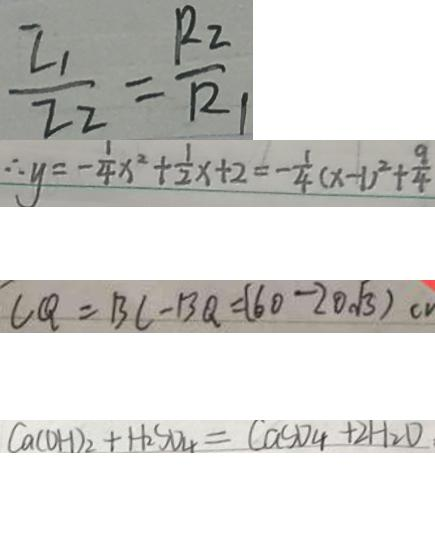<formula> <loc_0><loc_0><loc_500><loc_500>\frac { I _ { 1 } } { I _ { 2 } } = \frac { R 2 } { R _ { 1 } } 
 \therefore y = - \frac { 1 } { 4 } x ^ { 2 } + \frac { 1 } { 2 } x + 2 = - \frac { 1 } { 4 } ( x - 1 ) ^ { 2 } + \frac { 9 } { 4 } 
 C Q = B C - B Q = ( 6 0 - 2 0 \sqrt { 3 } ) c v 
 C a ( O H ) _ { 2 } + H _ { 2 } S O _ { 4 } = C a C O _ { 4 } + 2 H _ { 2 } O</formula> 